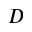Convert formula to latex. <formula><loc_0><loc_0><loc_500><loc_500>D</formula> 